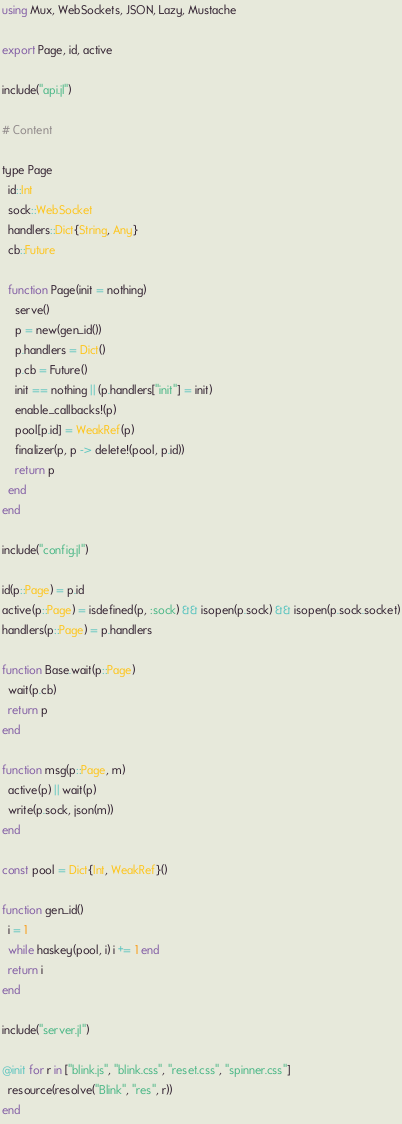Convert code to text. <code><loc_0><loc_0><loc_500><loc_500><_Julia_>using Mux, WebSockets, JSON, Lazy, Mustache

export Page, id, active

include("api.jl")

# Content

type Page
  id::Int
  sock::WebSocket
  handlers::Dict{String, Any}
  cb::Future

  function Page(init = nothing)
    serve()
    p = new(gen_id())
    p.handlers = Dict()
    p.cb = Future()
    init == nothing || (p.handlers["init"] = init)
    enable_callbacks!(p)
    pool[p.id] = WeakRef(p)
    finalizer(p, p -> delete!(pool, p.id))
    return p
  end
end

include("config.jl")

id(p::Page) = p.id
active(p::Page) = isdefined(p, :sock) && isopen(p.sock) && isopen(p.sock.socket)
handlers(p::Page) = p.handlers

function Base.wait(p::Page)
  wait(p.cb)
  return p
end

function msg(p::Page, m)
  active(p) || wait(p)
  write(p.sock, json(m))
end

const pool = Dict{Int, WeakRef}()

function gen_id()
  i = 1
  while haskey(pool, i) i += 1 end
  return i
end

include("server.jl")

@init for r in ["blink.js", "blink.css", "reset.css", "spinner.css"]
  resource(resolve("Blink", "res", r))
end
</code> 